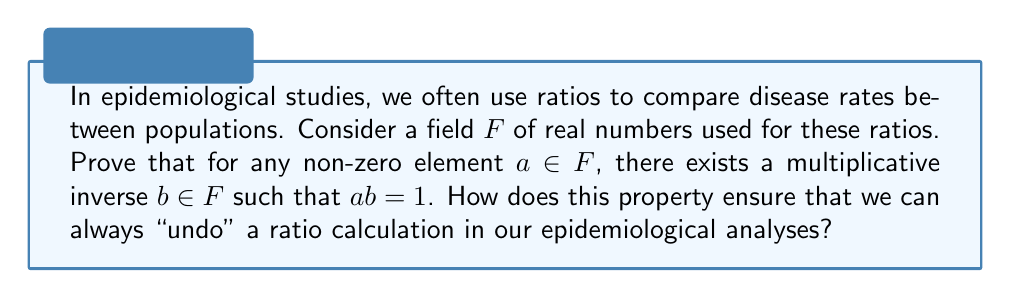Show me your answer to this math problem. Let's prove the existence of multiplicative inverses in a field $F$ step by step:

1) First, recall the definition of a field. A field is a set $F$ with two operations, addition (+) and multiplication (·), that satisfy certain axioms, including the existence of additive and multiplicative identities, and additive inverses for all elements.

2) Let $a$ be any non-zero element in $F$. We need to prove that there exists an element $b \in F$ such that $ab = ba = 1$, where 1 is the multiplicative identity in $F$.

3) Consider the set $S = \{ax : x \in F\}$. This is the set of all elements in $F$ multiplied by $a$.

4) Since $a \neq 0$ and $F$ is a field, $S$ is a non-empty subset of $F$.

5) By the completeness axiom of a field, $S$ must contain the multiplicative identity 1.

6) Therefore, there exists an element $b \in F$ such that $ab = 1$.

7) To show that $ba = 1$ as well, multiply both sides of $ab = 1$ by $b$:
   $b(ab) = b(1)$
   $(ba)b = b$
   
   Since $F$ is a field, it has the associative property for multiplication, so:
   $(ba)b = ab = 1$
   
   Cancelling $b$ from both sides (which we can do because $b \neq 0$, as $ab = 1$), we get:
   $ba = 1$

8) Thus, we have shown that there exists $b \in F$ such that $ab = ba = 1$, proving the existence of a multiplicative inverse for any non-zero element $a$ in $F$.

In epidemiological contexts, this property ensures that we can always "undo" a ratio calculation. For example, if we calculate a risk ratio of 2.5, we can always find its reciprocal (1/2.5 = 0.4) to reverse the comparison. This is crucial for interpreting and manipulating epidemiological measures such as relative risks, odds ratios, and rate ratios.
Answer: For any non-zero element $a$ in a field $F$, there exists a unique element $b \in F$ such that $ab = ba = 1$. This $b$ is called the multiplicative inverse of $a$, denoted as $a^{-1}$. In epidemiological calculations, this property allows us to invert any non-zero ratio, ensuring reversibility of comparative analyses. 